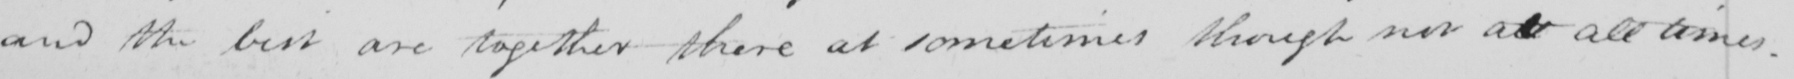What is written in this line of handwriting? and the best are together there at sometimes though not at all times . 